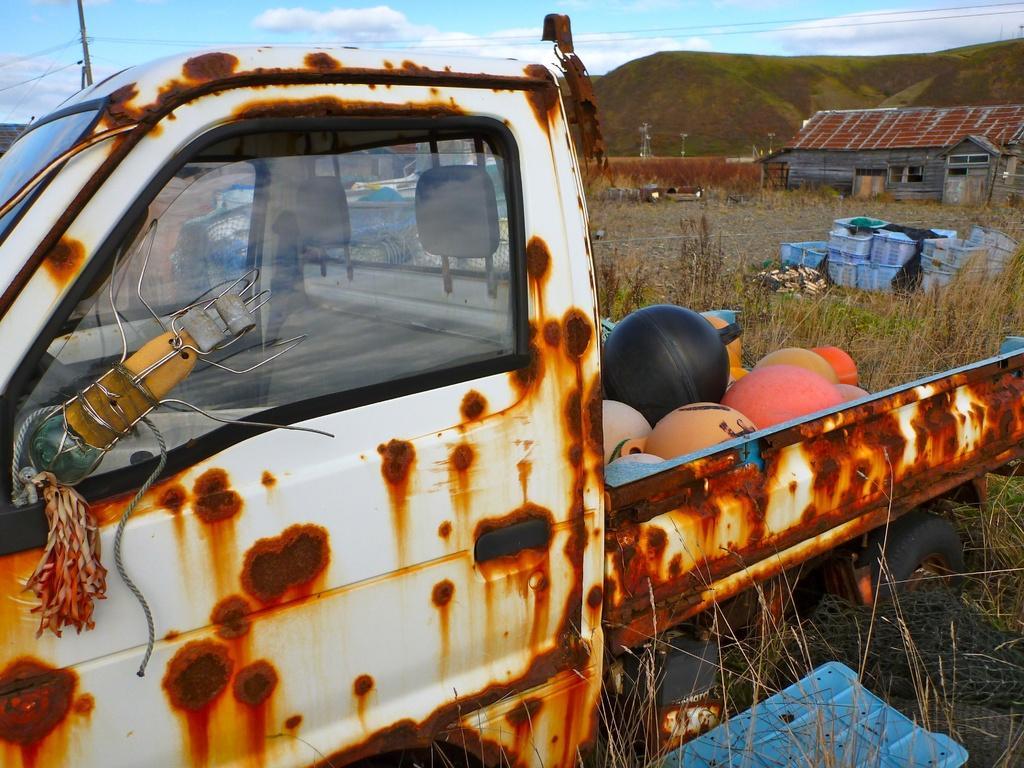Describe this image in one or two sentences. In this image there is a van in a field, in that van there are some objects, in the background there are boxes and a house mountains and a sky. 